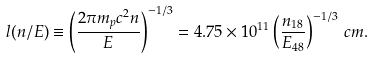<formula> <loc_0><loc_0><loc_500><loc_500>l ( n / E ) \equiv \left ( \frac { 2 \pi m _ { p } c ^ { 2 } n } { E } \right ) ^ { - 1 / 3 } = 4 . 7 5 \times 1 0 ^ { 1 1 } \left ( \frac { n _ { 1 8 } } { E _ { 4 8 } } \right ) ^ { - 1 / 3 } \, c m .</formula> 